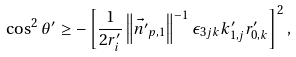<formula> <loc_0><loc_0><loc_500><loc_500>\cos ^ { 2 } \theta ^ { \prime } & \geq - \left [ \frac { 1 } { 2 r ^ { \prime } _ { i } } \left \| \vec { n ^ { \prime } } _ { p , 1 } \right \| ^ { - 1 } \epsilon _ { 3 j k } k ^ { \prime } _ { 1 , j } r ^ { \prime } _ { 0 , k } \right ] ^ { 2 } ,</formula> 